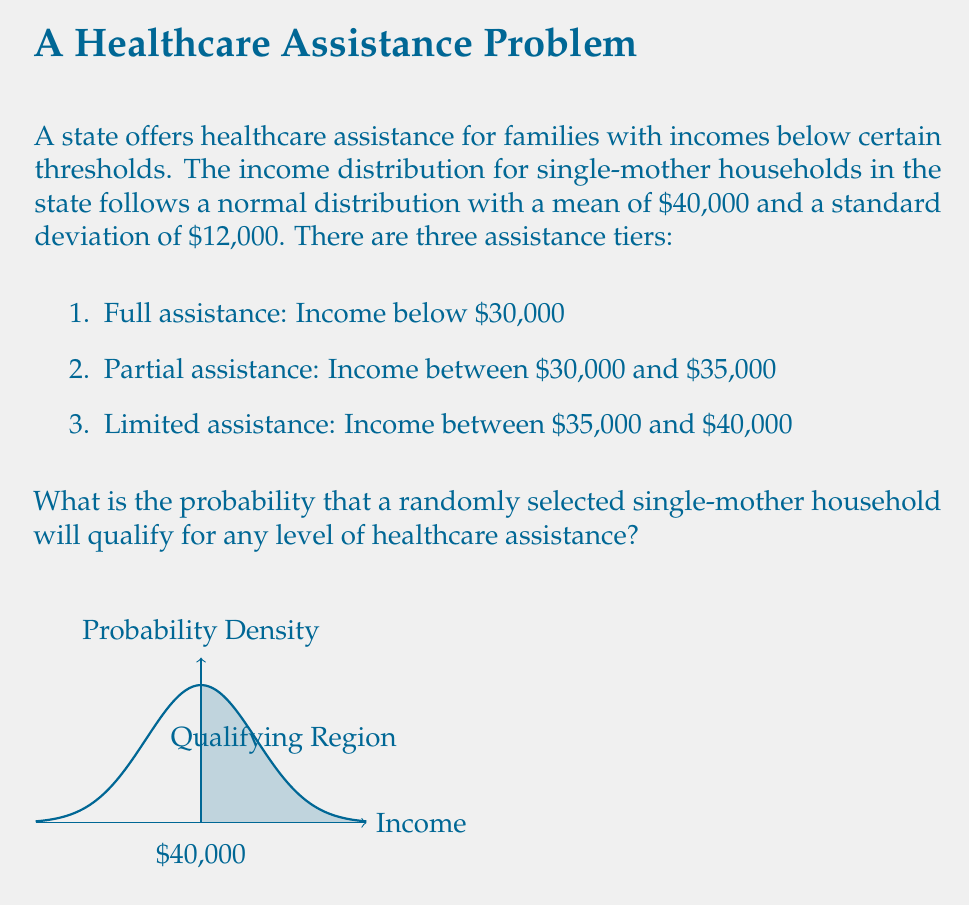Provide a solution to this math problem. To solve this problem, we need to calculate the cumulative probability for incomes up to $40,000 using the normal distribution.

Given:
- Mean income (μ) = $40,000
- Standard deviation (σ) = $12,000
- Upper limit for assistance = $40,000

Step 1: Calculate the z-score for the upper limit.
$z = \frac{x - μ}{σ} = \frac{40,000 - 40,000}{12,000} = 0$

Step 2: Use the standard normal distribution table or a calculator to find the cumulative probability for z = 0.
$P(Z ≤ 0) = 0.5$

This means that 50% of the distribution lies below the mean of $40,000.

Step 3: The question asks for the probability of qualifying for any level of assistance, which includes all incomes below $40,000. This is exactly what we calculated in Step 2.

Therefore, the probability that a randomly selected single-mother household will qualify for any level of healthcare assistance is 0.5 or 50%.
Answer: 0.5 